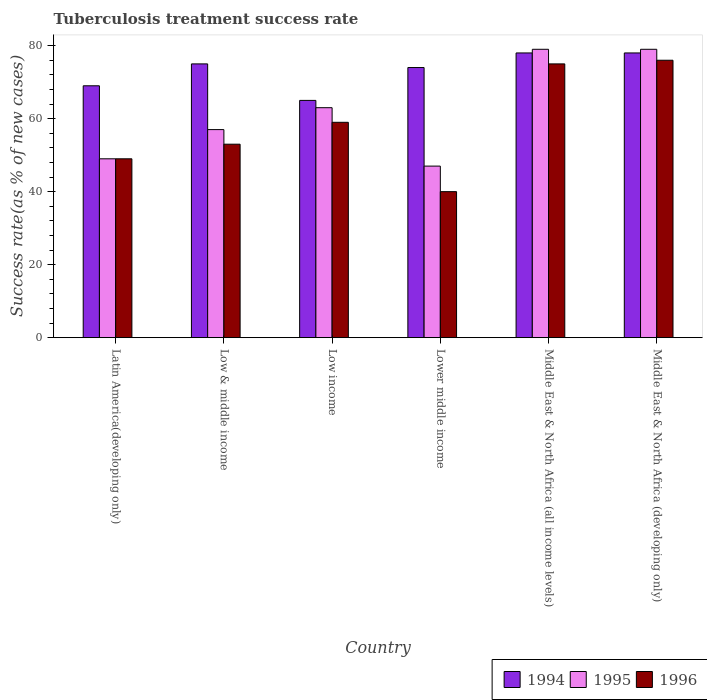Are the number of bars per tick equal to the number of legend labels?
Provide a short and direct response. Yes. Are the number of bars on each tick of the X-axis equal?
Make the answer very short. Yes. How many bars are there on the 3rd tick from the left?
Keep it short and to the point. 3. How many bars are there on the 5th tick from the right?
Keep it short and to the point. 3. What is the label of the 1st group of bars from the left?
Offer a terse response. Latin America(developing only). Across all countries, what is the minimum tuberculosis treatment success rate in 1995?
Provide a short and direct response. 47. In which country was the tuberculosis treatment success rate in 1996 maximum?
Provide a succinct answer. Middle East & North Africa (developing only). In which country was the tuberculosis treatment success rate in 1996 minimum?
Ensure brevity in your answer.  Lower middle income. What is the total tuberculosis treatment success rate in 1996 in the graph?
Ensure brevity in your answer.  352. What is the difference between the tuberculosis treatment success rate in 1995 in Low & middle income and that in Middle East & North Africa (all income levels)?
Offer a very short reply. -22. What is the average tuberculosis treatment success rate in 1995 per country?
Your response must be concise. 62.33. In how many countries, is the tuberculosis treatment success rate in 1994 greater than 44 %?
Keep it short and to the point. 6. What is the ratio of the tuberculosis treatment success rate in 1995 in Low income to that in Middle East & North Africa (all income levels)?
Provide a short and direct response. 0.8. Is the difference between the tuberculosis treatment success rate in 1994 in Latin America(developing only) and Lower middle income greater than the difference between the tuberculosis treatment success rate in 1995 in Latin America(developing only) and Lower middle income?
Your answer should be very brief. No. What is the difference between the highest and the second highest tuberculosis treatment success rate in 1995?
Your answer should be very brief. -16. In how many countries, is the tuberculosis treatment success rate in 1996 greater than the average tuberculosis treatment success rate in 1996 taken over all countries?
Your response must be concise. 3. Is the sum of the tuberculosis treatment success rate in 1995 in Low & middle income and Middle East & North Africa (developing only) greater than the maximum tuberculosis treatment success rate in 1996 across all countries?
Your answer should be compact. Yes. What does the 1st bar from the left in Lower middle income represents?
Keep it short and to the point. 1994. Is it the case that in every country, the sum of the tuberculosis treatment success rate in 1994 and tuberculosis treatment success rate in 1995 is greater than the tuberculosis treatment success rate in 1996?
Your answer should be compact. Yes. How many bars are there?
Your response must be concise. 18. Are all the bars in the graph horizontal?
Ensure brevity in your answer.  No. What is the difference between two consecutive major ticks on the Y-axis?
Offer a terse response. 20. Does the graph contain any zero values?
Your response must be concise. No. Where does the legend appear in the graph?
Give a very brief answer. Bottom right. What is the title of the graph?
Your answer should be compact. Tuberculosis treatment success rate. Does "1986" appear as one of the legend labels in the graph?
Keep it short and to the point. No. What is the label or title of the X-axis?
Offer a terse response. Country. What is the label or title of the Y-axis?
Your answer should be very brief. Success rate(as % of new cases). What is the Success rate(as % of new cases) of 1994 in Latin America(developing only)?
Make the answer very short. 69. What is the Success rate(as % of new cases) in 1995 in Latin America(developing only)?
Offer a terse response. 49. What is the Success rate(as % of new cases) of 1996 in Latin America(developing only)?
Provide a short and direct response. 49. What is the Success rate(as % of new cases) in 1994 in Low & middle income?
Offer a terse response. 75. What is the Success rate(as % of new cases) in 1995 in Low & middle income?
Keep it short and to the point. 57. What is the Success rate(as % of new cases) in 1995 in Low income?
Your answer should be very brief. 63. What is the Success rate(as % of new cases) of 1995 in Lower middle income?
Your answer should be very brief. 47. What is the Success rate(as % of new cases) of 1996 in Lower middle income?
Your answer should be compact. 40. What is the Success rate(as % of new cases) in 1994 in Middle East & North Africa (all income levels)?
Provide a short and direct response. 78. What is the Success rate(as % of new cases) of 1995 in Middle East & North Africa (all income levels)?
Provide a short and direct response. 79. What is the Success rate(as % of new cases) of 1996 in Middle East & North Africa (all income levels)?
Give a very brief answer. 75. What is the Success rate(as % of new cases) in 1995 in Middle East & North Africa (developing only)?
Make the answer very short. 79. Across all countries, what is the maximum Success rate(as % of new cases) of 1995?
Offer a very short reply. 79. Across all countries, what is the maximum Success rate(as % of new cases) of 1996?
Your response must be concise. 76. Across all countries, what is the minimum Success rate(as % of new cases) in 1994?
Offer a very short reply. 65. Across all countries, what is the minimum Success rate(as % of new cases) in 1995?
Offer a terse response. 47. Across all countries, what is the minimum Success rate(as % of new cases) of 1996?
Provide a succinct answer. 40. What is the total Success rate(as % of new cases) of 1994 in the graph?
Keep it short and to the point. 439. What is the total Success rate(as % of new cases) in 1995 in the graph?
Your response must be concise. 374. What is the total Success rate(as % of new cases) in 1996 in the graph?
Offer a very short reply. 352. What is the difference between the Success rate(as % of new cases) in 1996 in Latin America(developing only) and that in Low income?
Provide a succinct answer. -10. What is the difference between the Success rate(as % of new cases) in 1994 in Latin America(developing only) and that in Lower middle income?
Your answer should be compact. -5. What is the difference between the Success rate(as % of new cases) in 1995 in Latin America(developing only) and that in Lower middle income?
Offer a very short reply. 2. What is the difference between the Success rate(as % of new cases) of 1996 in Latin America(developing only) and that in Middle East & North Africa (all income levels)?
Your answer should be compact. -26. What is the difference between the Success rate(as % of new cases) in 1996 in Latin America(developing only) and that in Middle East & North Africa (developing only)?
Offer a terse response. -27. What is the difference between the Success rate(as % of new cases) in 1994 in Low & middle income and that in Lower middle income?
Give a very brief answer. 1. What is the difference between the Success rate(as % of new cases) of 1995 in Low & middle income and that in Lower middle income?
Your answer should be compact. 10. What is the difference between the Success rate(as % of new cases) in 1994 in Low & middle income and that in Middle East & North Africa (all income levels)?
Give a very brief answer. -3. What is the difference between the Success rate(as % of new cases) of 1995 in Low & middle income and that in Middle East & North Africa (all income levels)?
Make the answer very short. -22. What is the difference between the Success rate(as % of new cases) in 1995 in Low & middle income and that in Middle East & North Africa (developing only)?
Your answer should be compact. -22. What is the difference between the Success rate(as % of new cases) of 1996 in Low & middle income and that in Middle East & North Africa (developing only)?
Give a very brief answer. -23. What is the difference between the Success rate(as % of new cases) in 1995 in Low income and that in Lower middle income?
Your response must be concise. 16. What is the difference between the Success rate(as % of new cases) in 1996 in Low income and that in Lower middle income?
Offer a terse response. 19. What is the difference between the Success rate(as % of new cases) in 1994 in Low income and that in Middle East & North Africa (all income levels)?
Offer a very short reply. -13. What is the difference between the Success rate(as % of new cases) in 1995 in Low income and that in Middle East & North Africa (all income levels)?
Keep it short and to the point. -16. What is the difference between the Success rate(as % of new cases) in 1994 in Low income and that in Middle East & North Africa (developing only)?
Give a very brief answer. -13. What is the difference between the Success rate(as % of new cases) of 1994 in Lower middle income and that in Middle East & North Africa (all income levels)?
Keep it short and to the point. -4. What is the difference between the Success rate(as % of new cases) of 1995 in Lower middle income and that in Middle East & North Africa (all income levels)?
Offer a terse response. -32. What is the difference between the Success rate(as % of new cases) in 1996 in Lower middle income and that in Middle East & North Africa (all income levels)?
Your answer should be very brief. -35. What is the difference between the Success rate(as % of new cases) of 1995 in Lower middle income and that in Middle East & North Africa (developing only)?
Keep it short and to the point. -32. What is the difference between the Success rate(as % of new cases) of 1996 in Lower middle income and that in Middle East & North Africa (developing only)?
Your answer should be compact. -36. What is the difference between the Success rate(as % of new cases) in 1994 in Latin America(developing only) and the Success rate(as % of new cases) in 1995 in Low & middle income?
Give a very brief answer. 12. What is the difference between the Success rate(as % of new cases) in 1994 in Latin America(developing only) and the Success rate(as % of new cases) in 1996 in Low & middle income?
Ensure brevity in your answer.  16. What is the difference between the Success rate(as % of new cases) of 1995 in Latin America(developing only) and the Success rate(as % of new cases) of 1996 in Low & middle income?
Your answer should be very brief. -4. What is the difference between the Success rate(as % of new cases) in 1994 in Latin America(developing only) and the Success rate(as % of new cases) in 1996 in Low income?
Provide a short and direct response. 10. What is the difference between the Success rate(as % of new cases) in 1994 in Latin America(developing only) and the Success rate(as % of new cases) in 1995 in Lower middle income?
Your answer should be compact. 22. What is the difference between the Success rate(as % of new cases) in 1995 in Latin America(developing only) and the Success rate(as % of new cases) in 1996 in Lower middle income?
Keep it short and to the point. 9. What is the difference between the Success rate(as % of new cases) of 1994 in Latin America(developing only) and the Success rate(as % of new cases) of 1995 in Middle East & North Africa (developing only)?
Make the answer very short. -10. What is the difference between the Success rate(as % of new cases) of 1994 in Low & middle income and the Success rate(as % of new cases) of 1996 in Low income?
Your response must be concise. 16. What is the difference between the Success rate(as % of new cases) of 1994 in Low & middle income and the Success rate(as % of new cases) of 1996 in Lower middle income?
Make the answer very short. 35. What is the difference between the Success rate(as % of new cases) in 1994 in Low & middle income and the Success rate(as % of new cases) in 1995 in Middle East & North Africa (all income levels)?
Keep it short and to the point. -4. What is the difference between the Success rate(as % of new cases) of 1995 in Low & middle income and the Success rate(as % of new cases) of 1996 in Middle East & North Africa (all income levels)?
Provide a succinct answer. -18. What is the difference between the Success rate(as % of new cases) in 1994 in Low & middle income and the Success rate(as % of new cases) in 1995 in Middle East & North Africa (developing only)?
Your answer should be compact. -4. What is the difference between the Success rate(as % of new cases) in 1995 in Low & middle income and the Success rate(as % of new cases) in 1996 in Middle East & North Africa (developing only)?
Make the answer very short. -19. What is the difference between the Success rate(as % of new cases) of 1994 in Low income and the Success rate(as % of new cases) of 1995 in Lower middle income?
Your answer should be very brief. 18. What is the difference between the Success rate(as % of new cases) in 1995 in Low income and the Success rate(as % of new cases) in 1996 in Lower middle income?
Provide a succinct answer. 23. What is the difference between the Success rate(as % of new cases) in 1995 in Low income and the Success rate(as % of new cases) in 1996 in Middle East & North Africa (all income levels)?
Give a very brief answer. -12. What is the difference between the Success rate(as % of new cases) in 1994 in Low income and the Success rate(as % of new cases) in 1996 in Middle East & North Africa (developing only)?
Make the answer very short. -11. What is the difference between the Success rate(as % of new cases) in 1995 in Low income and the Success rate(as % of new cases) in 1996 in Middle East & North Africa (developing only)?
Offer a very short reply. -13. What is the difference between the Success rate(as % of new cases) of 1995 in Lower middle income and the Success rate(as % of new cases) of 1996 in Middle East & North Africa (developing only)?
Your answer should be compact. -29. What is the difference between the Success rate(as % of new cases) of 1994 in Middle East & North Africa (all income levels) and the Success rate(as % of new cases) of 1995 in Middle East & North Africa (developing only)?
Ensure brevity in your answer.  -1. What is the difference between the Success rate(as % of new cases) of 1995 in Middle East & North Africa (all income levels) and the Success rate(as % of new cases) of 1996 in Middle East & North Africa (developing only)?
Ensure brevity in your answer.  3. What is the average Success rate(as % of new cases) of 1994 per country?
Your response must be concise. 73.17. What is the average Success rate(as % of new cases) in 1995 per country?
Keep it short and to the point. 62.33. What is the average Success rate(as % of new cases) in 1996 per country?
Give a very brief answer. 58.67. What is the difference between the Success rate(as % of new cases) in 1994 and Success rate(as % of new cases) in 1995 in Latin America(developing only)?
Your answer should be compact. 20. What is the difference between the Success rate(as % of new cases) in 1994 and Success rate(as % of new cases) in 1996 in Low & middle income?
Offer a very short reply. 22. What is the difference between the Success rate(as % of new cases) in 1995 and Success rate(as % of new cases) in 1996 in Low income?
Keep it short and to the point. 4. What is the difference between the Success rate(as % of new cases) in 1994 and Success rate(as % of new cases) in 1995 in Middle East & North Africa (all income levels)?
Give a very brief answer. -1. What is the difference between the Success rate(as % of new cases) of 1994 and Success rate(as % of new cases) of 1996 in Middle East & North Africa (all income levels)?
Keep it short and to the point. 3. What is the difference between the Success rate(as % of new cases) of 1995 and Success rate(as % of new cases) of 1996 in Middle East & North Africa (all income levels)?
Ensure brevity in your answer.  4. What is the difference between the Success rate(as % of new cases) of 1994 and Success rate(as % of new cases) of 1995 in Middle East & North Africa (developing only)?
Your answer should be compact. -1. What is the difference between the Success rate(as % of new cases) of 1994 and Success rate(as % of new cases) of 1996 in Middle East & North Africa (developing only)?
Give a very brief answer. 2. What is the difference between the Success rate(as % of new cases) of 1995 and Success rate(as % of new cases) of 1996 in Middle East & North Africa (developing only)?
Offer a very short reply. 3. What is the ratio of the Success rate(as % of new cases) in 1995 in Latin America(developing only) to that in Low & middle income?
Make the answer very short. 0.86. What is the ratio of the Success rate(as % of new cases) in 1996 in Latin America(developing only) to that in Low & middle income?
Offer a very short reply. 0.92. What is the ratio of the Success rate(as % of new cases) in 1994 in Latin America(developing only) to that in Low income?
Keep it short and to the point. 1.06. What is the ratio of the Success rate(as % of new cases) of 1995 in Latin America(developing only) to that in Low income?
Your response must be concise. 0.78. What is the ratio of the Success rate(as % of new cases) in 1996 in Latin America(developing only) to that in Low income?
Your answer should be very brief. 0.83. What is the ratio of the Success rate(as % of new cases) of 1994 in Latin America(developing only) to that in Lower middle income?
Keep it short and to the point. 0.93. What is the ratio of the Success rate(as % of new cases) in 1995 in Latin America(developing only) to that in Lower middle income?
Give a very brief answer. 1.04. What is the ratio of the Success rate(as % of new cases) in 1996 in Latin America(developing only) to that in Lower middle income?
Provide a succinct answer. 1.23. What is the ratio of the Success rate(as % of new cases) in 1994 in Latin America(developing only) to that in Middle East & North Africa (all income levels)?
Provide a short and direct response. 0.88. What is the ratio of the Success rate(as % of new cases) of 1995 in Latin America(developing only) to that in Middle East & North Africa (all income levels)?
Offer a very short reply. 0.62. What is the ratio of the Success rate(as % of new cases) in 1996 in Latin America(developing only) to that in Middle East & North Africa (all income levels)?
Give a very brief answer. 0.65. What is the ratio of the Success rate(as % of new cases) in 1994 in Latin America(developing only) to that in Middle East & North Africa (developing only)?
Provide a short and direct response. 0.88. What is the ratio of the Success rate(as % of new cases) of 1995 in Latin America(developing only) to that in Middle East & North Africa (developing only)?
Make the answer very short. 0.62. What is the ratio of the Success rate(as % of new cases) in 1996 in Latin America(developing only) to that in Middle East & North Africa (developing only)?
Offer a terse response. 0.64. What is the ratio of the Success rate(as % of new cases) in 1994 in Low & middle income to that in Low income?
Give a very brief answer. 1.15. What is the ratio of the Success rate(as % of new cases) in 1995 in Low & middle income to that in Low income?
Make the answer very short. 0.9. What is the ratio of the Success rate(as % of new cases) in 1996 in Low & middle income to that in Low income?
Offer a terse response. 0.9. What is the ratio of the Success rate(as % of new cases) in 1994 in Low & middle income to that in Lower middle income?
Your response must be concise. 1.01. What is the ratio of the Success rate(as % of new cases) of 1995 in Low & middle income to that in Lower middle income?
Provide a succinct answer. 1.21. What is the ratio of the Success rate(as % of new cases) in 1996 in Low & middle income to that in Lower middle income?
Give a very brief answer. 1.32. What is the ratio of the Success rate(as % of new cases) of 1994 in Low & middle income to that in Middle East & North Africa (all income levels)?
Provide a succinct answer. 0.96. What is the ratio of the Success rate(as % of new cases) of 1995 in Low & middle income to that in Middle East & North Africa (all income levels)?
Give a very brief answer. 0.72. What is the ratio of the Success rate(as % of new cases) in 1996 in Low & middle income to that in Middle East & North Africa (all income levels)?
Your answer should be very brief. 0.71. What is the ratio of the Success rate(as % of new cases) of 1994 in Low & middle income to that in Middle East & North Africa (developing only)?
Offer a terse response. 0.96. What is the ratio of the Success rate(as % of new cases) of 1995 in Low & middle income to that in Middle East & North Africa (developing only)?
Offer a very short reply. 0.72. What is the ratio of the Success rate(as % of new cases) in 1996 in Low & middle income to that in Middle East & North Africa (developing only)?
Your answer should be very brief. 0.7. What is the ratio of the Success rate(as % of new cases) in 1994 in Low income to that in Lower middle income?
Provide a succinct answer. 0.88. What is the ratio of the Success rate(as % of new cases) in 1995 in Low income to that in Lower middle income?
Your response must be concise. 1.34. What is the ratio of the Success rate(as % of new cases) in 1996 in Low income to that in Lower middle income?
Make the answer very short. 1.48. What is the ratio of the Success rate(as % of new cases) in 1995 in Low income to that in Middle East & North Africa (all income levels)?
Offer a very short reply. 0.8. What is the ratio of the Success rate(as % of new cases) of 1996 in Low income to that in Middle East & North Africa (all income levels)?
Offer a very short reply. 0.79. What is the ratio of the Success rate(as % of new cases) in 1994 in Low income to that in Middle East & North Africa (developing only)?
Your answer should be compact. 0.83. What is the ratio of the Success rate(as % of new cases) in 1995 in Low income to that in Middle East & North Africa (developing only)?
Give a very brief answer. 0.8. What is the ratio of the Success rate(as % of new cases) of 1996 in Low income to that in Middle East & North Africa (developing only)?
Offer a very short reply. 0.78. What is the ratio of the Success rate(as % of new cases) of 1994 in Lower middle income to that in Middle East & North Africa (all income levels)?
Offer a terse response. 0.95. What is the ratio of the Success rate(as % of new cases) in 1995 in Lower middle income to that in Middle East & North Africa (all income levels)?
Provide a short and direct response. 0.59. What is the ratio of the Success rate(as % of new cases) in 1996 in Lower middle income to that in Middle East & North Africa (all income levels)?
Ensure brevity in your answer.  0.53. What is the ratio of the Success rate(as % of new cases) of 1994 in Lower middle income to that in Middle East & North Africa (developing only)?
Your answer should be very brief. 0.95. What is the ratio of the Success rate(as % of new cases) in 1995 in Lower middle income to that in Middle East & North Africa (developing only)?
Provide a short and direct response. 0.59. What is the ratio of the Success rate(as % of new cases) in 1996 in Lower middle income to that in Middle East & North Africa (developing only)?
Offer a very short reply. 0.53. What is the ratio of the Success rate(as % of new cases) of 1994 in Middle East & North Africa (all income levels) to that in Middle East & North Africa (developing only)?
Offer a terse response. 1. What is the ratio of the Success rate(as % of new cases) of 1995 in Middle East & North Africa (all income levels) to that in Middle East & North Africa (developing only)?
Make the answer very short. 1. What is the ratio of the Success rate(as % of new cases) in 1996 in Middle East & North Africa (all income levels) to that in Middle East & North Africa (developing only)?
Provide a short and direct response. 0.99. What is the difference between the highest and the lowest Success rate(as % of new cases) in 1994?
Your answer should be compact. 13. 